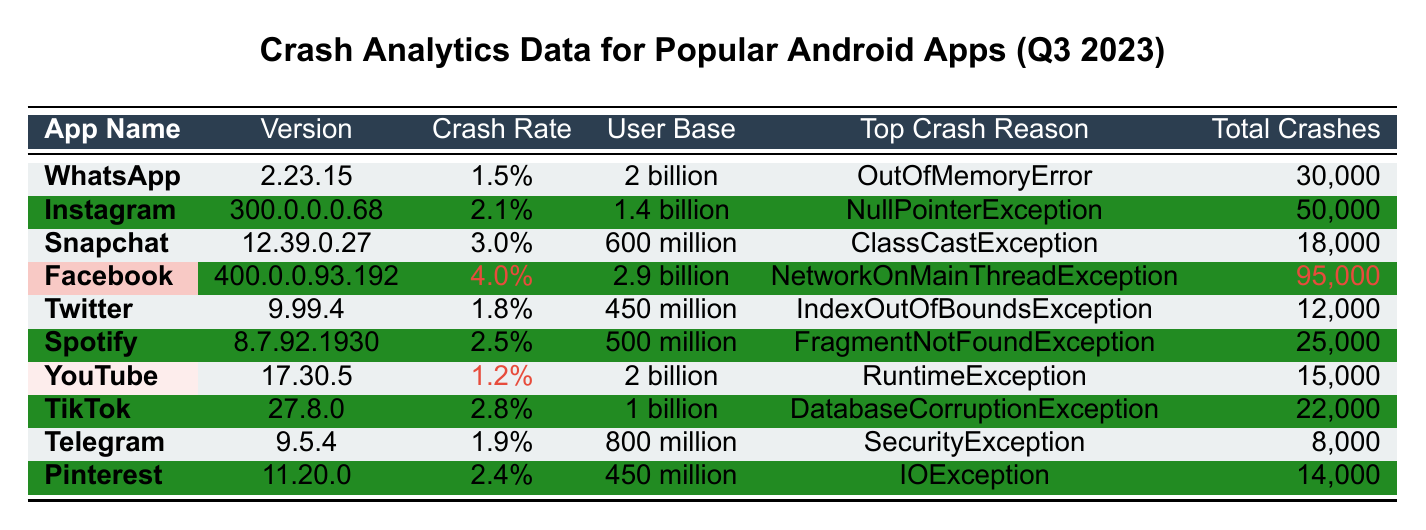What is the crash rate for Instagram? The crash rate for Instagram is listed in the table under the "Crash Rate" column for the row corresponding to Instagram. It is 2.1%.
Answer: 2.1% Which app has the highest total crashes? By examining the "Total Crashes" column, we find that Facebook has the highest number of total crashes at 95,000.
Answer: Facebook What percentage of the user base does Snapchat's crash rate represent? The crash rate for Snapchat is 3.0%, and its user base is 600 million. To find the percentage of the user base that represents the crashes, we can multiply the user base by the crash rate: 600 million * 3.0% = 18 million.
Answer: 18 million Which app has the lowest crash rate? From the "Crash Rate" column, we can see that YouTube has the lowest crash rate at 1.2%.
Answer: YouTube Is the top crash reason for Spotify a NullPointerException? Looking under the "Top Crash Reason" column for Spotify, the reason is FragmentNotFoundException, not NullPointerException. Therefore, the statement is false.
Answer: No Which two apps have a combined total of crashes greater than 100,000? Checking the "Total Crashes" column, Facebook (95,000) and Instagram (50,000) combined give us 145,000, which is greater than 100,000.
Answer: Facebook and Instagram What is the average crash rate of the apps listed? To calculate the average crash rate, we first convert the percentages to decimals: (1.5 + 2.1 + 3.0 + 4.0 + 1.8 + 2.5 + 1.2 + 2.8 + 1.9 + 2.4) / 10 = 2.12%.
Answer: 2.12% Which app has both a crash rate and total crashes higher than WhatsApp? Comparing WhatsApp, which has a crash rate of 1.5% and total crashes of 30,000, we see that Facebook (4.0% and 95,000) and Instagram (2.1% and 50,000) both exceed these figures.
Answer: Facebook and Instagram What is the difference in total crashes between Telegram and Pinterest? By subtracting the total crashes for Telegram (8,000) from Pinterest (14,000), we find that the difference is 14,000 - 8,000 = 6,000.
Answer: 6,000 Which app has a higher user base: Spotify or Twitter? Looking at the user base values, Spotify has 500 million, while Twitter has 450 million, so Spotify has a higher user base.
Answer: Spotify 